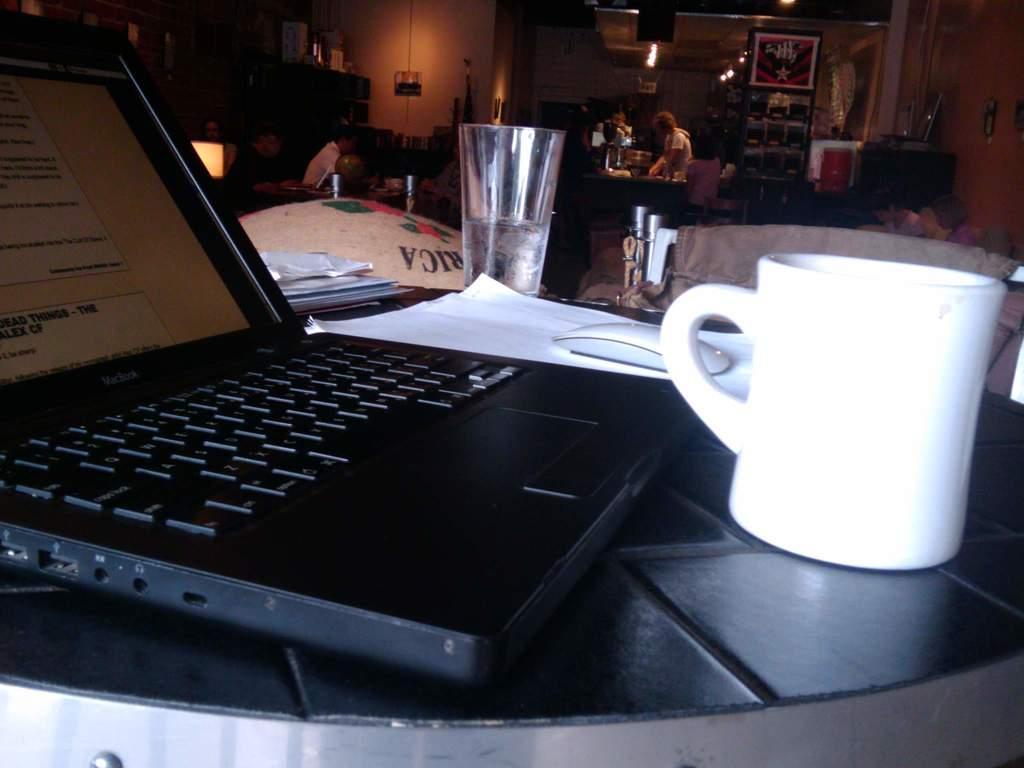Could you give a brief overview of what you see in this image? In the foreground of the image we can see a laptop, mouse, group of papers, glass cup and placed on the table. In the background, we can see some persons, photo frames on walls, cupboards and some lights 